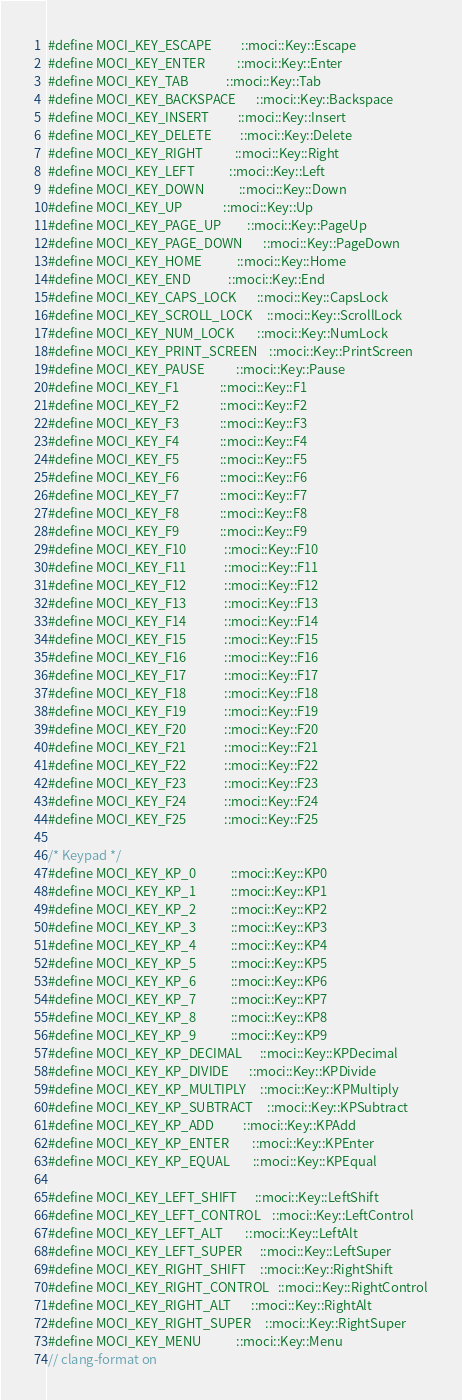<code> <loc_0><loc_0><loc_500><loc_500><_C++_>#define MOCI_KEY_ESCAPE          ::moci::Key::Escape
#define MOCI_KEY_ENTER           ::moci::Key::Enter
#define MOCI_KEY_TAB             ::moci::Key::Tab
#define MOCI_KEY_BACKSPACE       ::moci::Key::Backspace
#define MOCI_KEY_INSERT          ::moci::Key::Insert
#define MOCI_KEY_DELETE          ::moci::Key::Delete
#define MOCI_KEY_RIGHT           ::moci::Key::Right
#define MOCI_KEY_LEFT            ::moci::Key::Left
#define MOCI_KEY_DOWN            ::moci::Key::Down
#define MOCI_KEY_UP              ::moci::Key::Up
#define MOCI_KEY_PAGE_UP         ::moci::Key::PageUp
#define MOCI_KEY_PAGE_DOWN       ::moci::Key::PageDown
#define MOCI_KEY_HOME            ::moci::Key::Home
#define MOCI_KEY_END             ::moci::Key::End
#define MOCI_KEY_CAPS_LOCK       ::moci::Key::CapsLock
#define MOCI_KEY_SCROLL_LOCK     ::moci::Key::ScrollLock
#define MOCI_KEY_NUM_LOCK        ::moci::Key::NumLock
#define MOCI_KEY_PRINT_SCREEN    ::moci::Key::PrintScreen
#define MOCI_KEY_PAUSE           ::moci::Key::Pause
#define MOCI_KEY_F1              ::moci::Key::F1
#define MOCI_KEY_F2              ::moci::Key::F2
#define MOCI_KEY_F3              ::moci::Key::F3
#define MOCI_KEY_F4              ::moci::Key::F4
#define MOCI_KEY_F5              ::moci::Key::F5
#define MOCI_KEY_F6              ::moci::Key::F6
#define MOCI_KEY_F7              ::moci::Key::F7
#define MOCI_KEY_F8              ::moci::Key::F8
#define MOCI_KEY_F9              ::moci::Key::F9
#define MOCI_KEY_F10             ::moci::Key::F10
#define MOCI_KEY_F11             ::moci::Key::F11
#define MOCI_KEY_F12             ::moci::Key::F12
#define MOCI_KEY_F13             ::moci::Key::F13
#define MOCI_KEY_F14             ::moci::Key::F14
#define MOCI_KEY_F15             ::moci::Key::F15
#define MOCI_KEY_F16             ::moci::Key::F16
#define MOCI_KEY_F17             ::moci::Key::F17
#define MOCI_KEY_F18             ::moci::Key::F18
#define MOCI_KEY_F19             ::moci::Key::F19
#define MOCI_KEY_F20             ::moci::Key::F20
#define MOCI_KEY_F21             ::moci::Key::F21
#define MOCI_KEY_F22             ::moci::Key::F22
#define MOCI_KEY_F23             ::moci::Key::F23
#define MOCI_KEY_F24             ::moci::Key::F24
#define MOCI_KEY_F25             ::moci::Key::F25

/* Keypad */
#define MOCI_KEY_KP_0            ::moci::Key::KP0
#define MOCI_KEY_KP_1            ::moci::Key::KP1
#define MOCI_KEY_KP_2            ::moci::Key::KP2
#define MOCI_KEY_KP_3            ::moci::Key::KP3
#define MOCI_KEY_KP_4            ::moci::Key::KP4
#define MOCI_KEY_KP_5            ::moci::Key::KP5
#define MOCI_KEY_KP_6            ::moci::Key::KP6
#define MOCI_KEY_KP_7            ::moci::Key::KP7
#define MOCI_KEY_KP_8            ::moci::Key::KP8
#define MOCI_KEY_KP_9            ::moci::Key::KP9
#define MOCI_KEY_KP_DECIMAL      ::moci::Key::KPDecimal
#define MOCI_KEY_KP_DIVIDE       ::moci::Key::KPDivide
#define MOCI_KEY_KP_MULTIPLY     ::moci::Key::KPMultiply
#define MOCI_KEY_KP_SUBTRACT     ::moci::Key::KPSubtract
#define MOCI_KEY_KP_ADD          ::moci::Key::KPAdd
#define MOCI_KEY_KP_ENTER        ::moci::Key::KPEnter
#define MOCI_KEY_KP_EQUAL        ::moci::Key::KPEqual

#define MOCI_KEY_LEFT_SHIFT      ::moci::Key::LeftShift
#define MOCI_KEY_LEFT_CONTROL    ::moci::Key::LeftControl
#define MOCI_KEY_LEFT_ALT        ::moci::Key::LeftAlt
#define MOCI_KEY_LEFT_SUPER      ::moci::Key::LeftSuper
#define MOCI_KEY_RIGHT_SHIFT     ::moci::Key::RightShift
#define MOCI_KEY_RIGHT_CONTROL   ::moci::Key::RightControl
#define MOCI_KEY_RIGHT_ALT       ::moci::Key::RightAlt
#define MOCI_KEY_RIGHT_SUPER     ::moci::Key::RightSuper
#define MOCI_KEY_MENU            ::moci::Key::Menu
// clang-format on</code> 